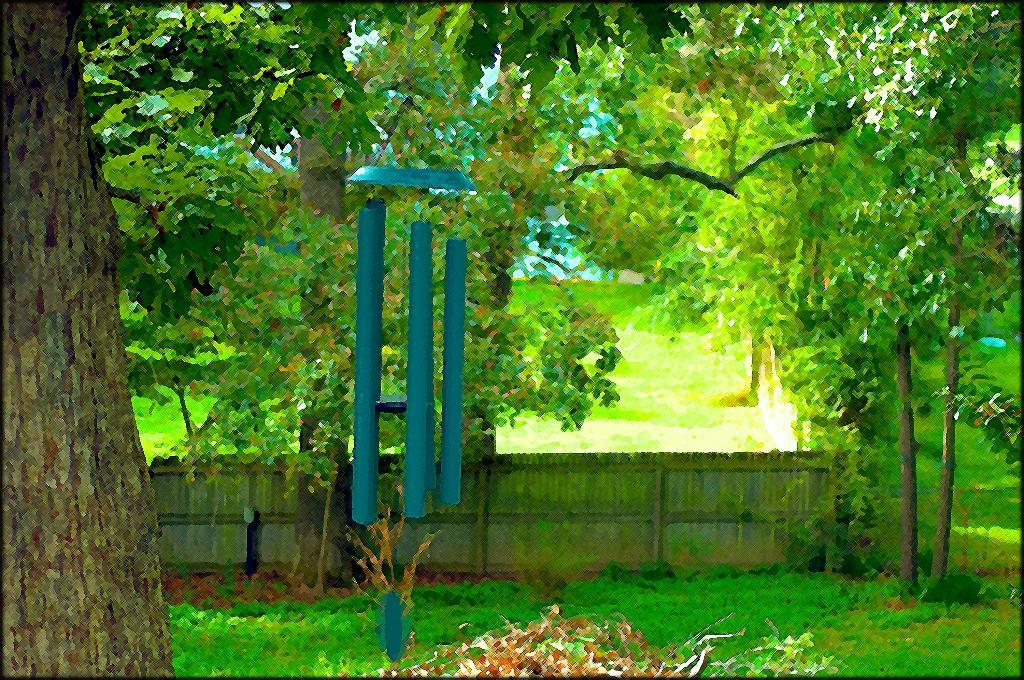What type of natural elements can be seen in the image? There are trees in the image. What is located in the middle of the image? There is a decorative element in the middle of the image. What type of structure is at the bottom of the image? There is a fence at the bottom of the image. How many stars can be seen in the image? There are no stars visible in the image. What type of lock is securing the decorative element in the image? There is no lock present in the image; the decorative element is not secured. 